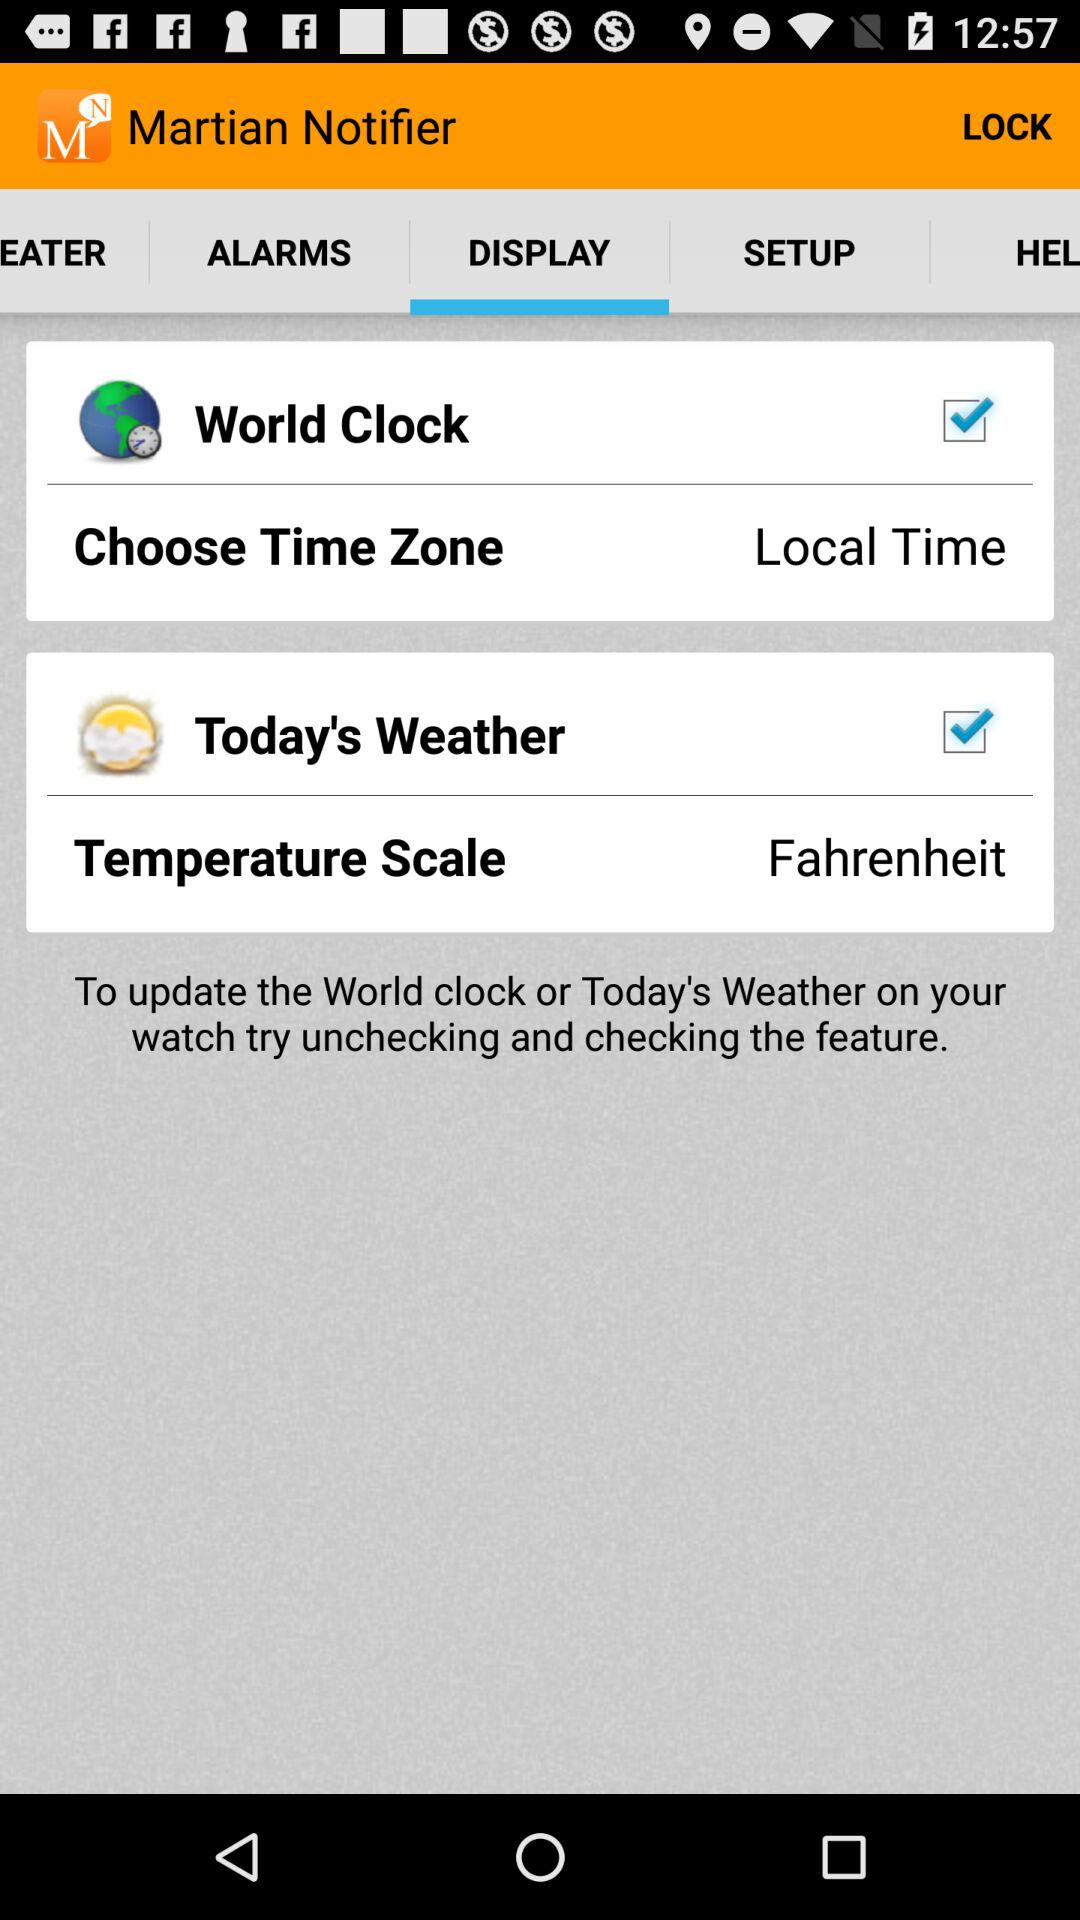Which option is checked? The checked options are "World Clock" and "Today's Weather". 